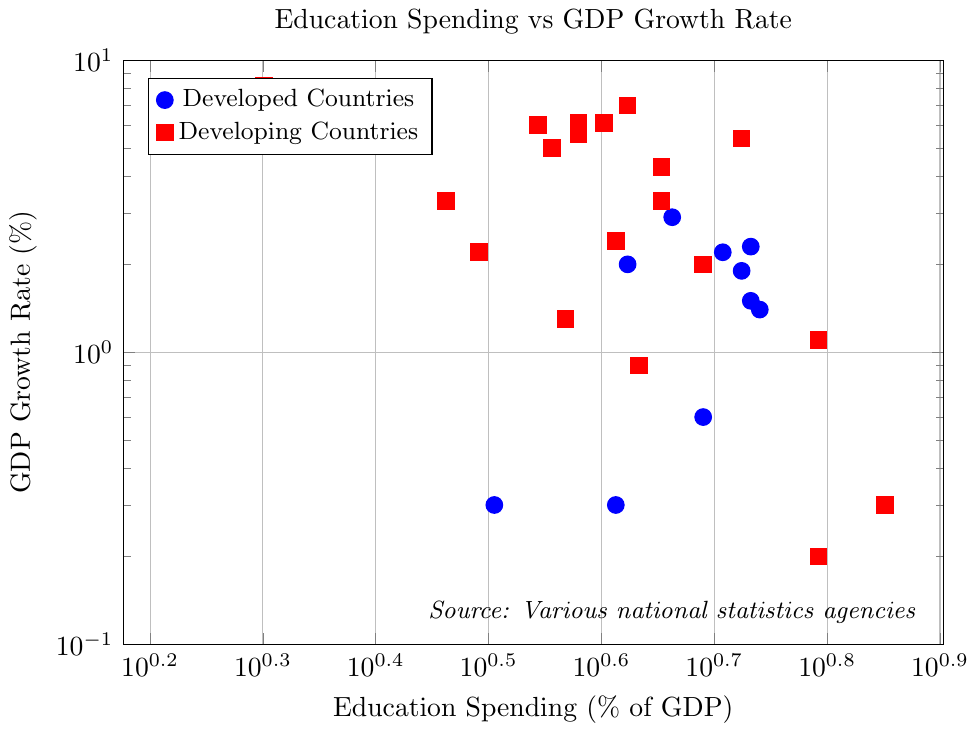Which country has the highest education spending as a percentage of GDP? Identify the point furthest to the right on the x-axis, which corresponds to the highest education spending. In this case, it's at 7.1%, corresponding to Saudi Arabia.
Answer: Saudi Arabia Which developed country has the highest GDP growth rate? Look for the blue markers and identify the one highest up on the y-axis. South Korea has the highest GDP growth rate among developed countries at 2.9%.
Answer: South Korea How does the GDP growth rate of Bangladesh compare to that of Vietnam? Find the markers for Bangladesh and Vietnam, both red squares. Compare their positions on the y-axis. Bangladesh is at 8.2% while Vietnam is at 7.0%.
Answer: Bangladesh's GDP growth rate is higher What is the average GDP growth rate for developed countries? Identify and sum the GDP growth rates for developed countries: (2.3 + 0.3 + 0.6 + 1.4 + 1.5 + 1.9 + 0.3 + 2.2 + 2.9 + 2.0). Divide by the number of developed countries, which is 10. The sum is 15.4. 15.4/10 = 1.54
Answer: 1.54 Which group of countries, developed or developing, has a wider range of education spending percentages? Identify the range of x-values for both groups: Developed countries have a range from 3.2% to 5.5% (range of 2.3%), while developing countries range from 2.0% to 7.1% (range of 5.1%).
Answer: Developing countries Which country has the lowest GDP growth rate and what is its education spending percentage? Look for the marker closest to the bottom of the y-axis. South Africa has the lowest GDP growth rate at 0.2%. It has an education spending of 6.2%.
Answer: South Africa, 6.2% How many developing countries have a GDP growth rate above 5%? Count the number of red markers above the 5% mark on the y-axis: India, China, Indonesia, Kenya, Vietnam, Bangladesh, and Philippines. There are 7 in total.
Answer: 7 Compare the GDP growth rates of the United States and India. Which one is higher and by how much? Locate the markers for the United States (2.3%) and India (6.1%). Subtract the smaller value from the larger one: 6.1 - 2.3 = 3.8.
Answer: India, by 3.8% What is the education spending percentage of the country with the highest GDP growth rate? Identify the marker highest up on the y-axis, corresponding to Bangladesh with an 8.2% GDP growth rate. Its education spending is at 2.0% of GDP.
Answer: 2.0% Which has more countries with a GDP growth rate below 1%, developed or developing countries? Count the markers below the 1% mark on the y-axis for both groups. Developed countries: Japan, Germany, Italy, and France (4). Developing countries: Saudi Arabia, South Africa, Argentina, and Brazil (4). Both groups have 4 countries each.
Answer: Tie 